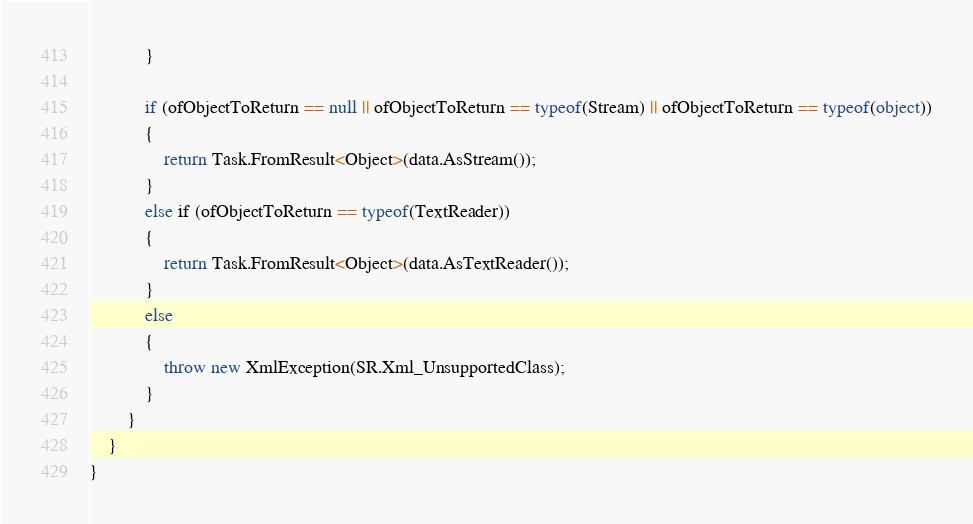Convert code to text. <code><loc_0><loc_0><loc_500><loc_500><_C#_>            }

            if (ofObjectToReturn == null || ofObjectToReturn == typeof(Stream) || ofObjectToReturn == typeof(object))
            {
                return Task.FromResult<Object>(data.AsStream());
            }
            else if (ofObjectToReturn == typeof(TextReader))
            {
                return Task.FromResult<Object>(data.AsTextReader());
            }
            else
            {
                throw new XmlException(SR.Xml_UnsupportedClass);
            }
        }
    }
}
</code> 